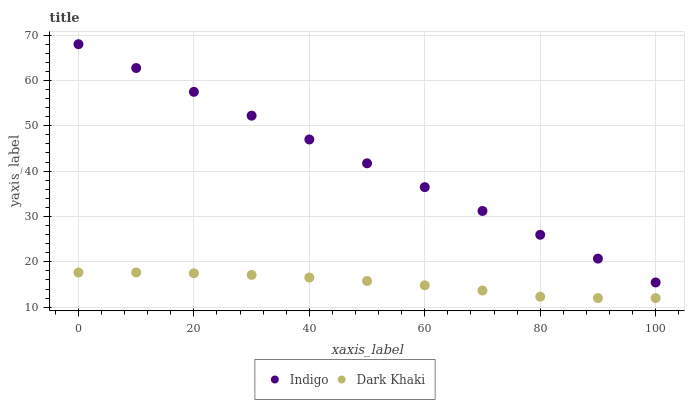Does Dark Khaki have the minimum area under the curve?
Answer yes or no. Yes. Does Indigo have the maximum area under the curve?
Answer yes or no. Yes. Does Indigo have the minimum area under the curve?
Answer yes or no. No. Is Indigo the smoothest?
Answer yes or no. Yes. Is Dark Khaki the roughest?
Answer yes or no. Yes. Is Indigo the roughest?
Answer yes or no. No. Does Dark Khaki have the lowest value?
Answer yes or no. Yes. Does Indigo have the lowest value?
Answer yes or no. No. Does Indigo have the highest value?
Answer yes or no. Yes. Is Dark Khaki less than Indigo?
Answer yes or no. Yes. Is Indigo greater than Dark Khaki?
Answer yes or no. Yes. Does Dark Khaki intersect Indigo?
Answer yes or no. No. 